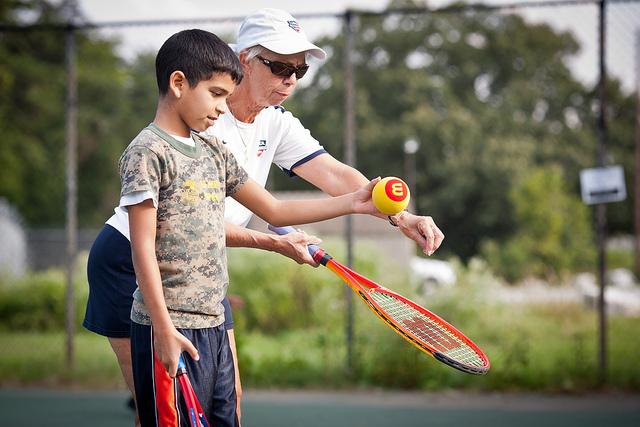What is the lady showing the boy?
Answer briefly. Tennis. What color hat is the woman wearing?
Concise answer only. White. What brand is featured in this photo?
Concise answer only. Wilson. 